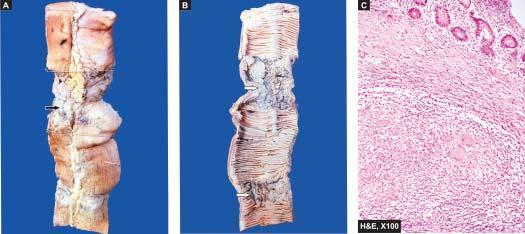what shows caseating epithelioid cell granulomas in the intestinal wall?
Answer the question using a single word or phrase. Microscopy of intestine 